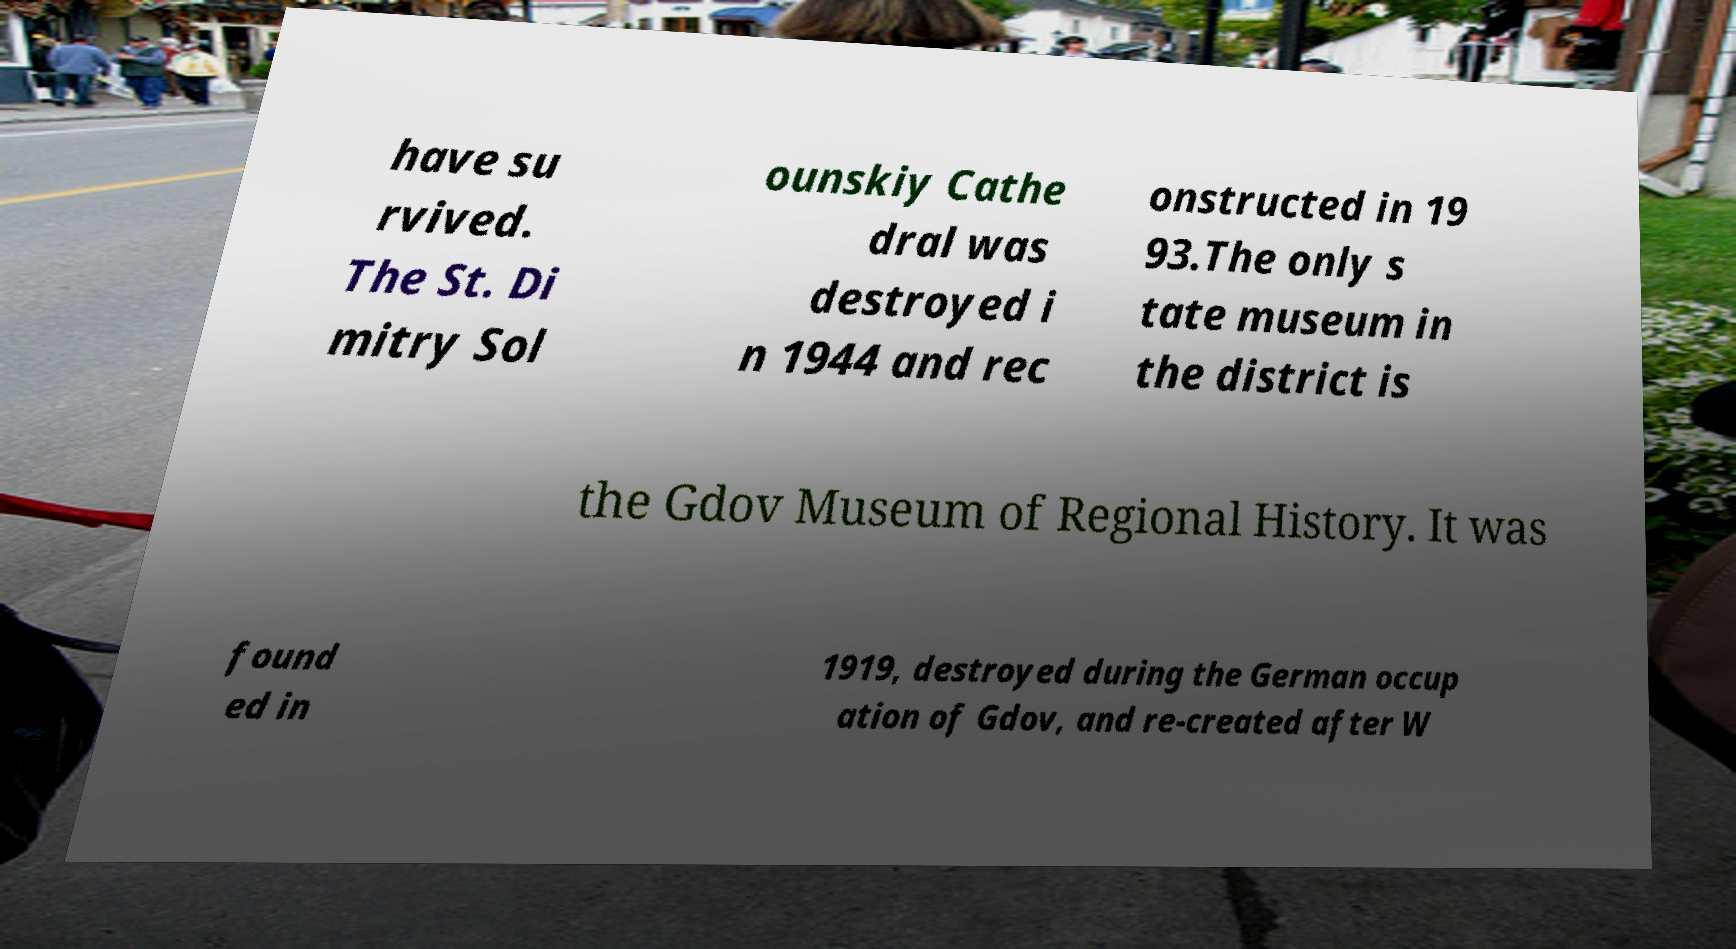There's text embedded in this image that I need extracted. Can you transcribe it verbatim? have su rvived. The St. Di mitry Sol ounskiy Cathe dral was destroyed i n 1944 and rec onstructed in 19 93.The only s tate museum in the district is the Gdov Museum of Regional History. It was found ed in 1919, destroyed during the German occup ation of Gdov, and re-created after W 